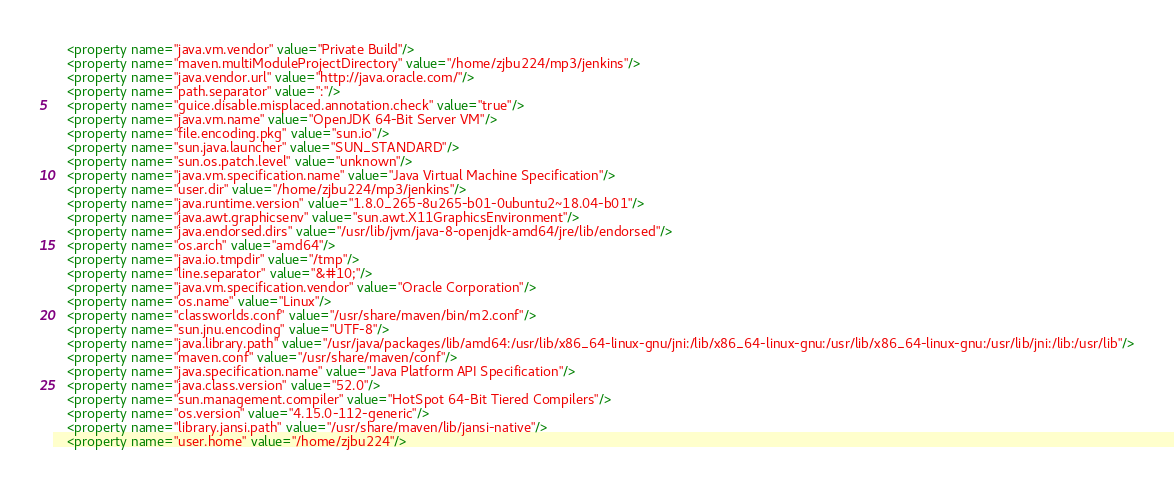<code> <loc_0><loc_0><loc_500><loc_500><_XML_>    <property name="java.vm.vendor" value="Private Build"/>
    <property name="maven.multiModuleProjectDirectory" value="/home/zjbu224/mp3/jenkins"/>
    <property name="java.vendor.url" value="http://java.oracle.com/"/>
    <property name="path.separator" value=":"/>
    <property name="guice.disable.misplaced.annotation.check" value="true"/>
    <property name="java.vm.name" value="OpenJDK 64-Bit Server VM"/>
    <property name="file.encoding.pkg" value="sun.io"/>
    <property name="sun.java.launcher" value="SUN_STANDARD"/>
    <property name="sun.os.patch.level" value="unknown"/>
    <property name="java.vm.specification.name" value="Java Virtual Machine Specification"/>
    <property name="user.dir" value="/home/zjbu224/mp3/jenkins"/>
    <property name="java.runtime.version" value="1.8.0_265-8u265-b01-0ubuntu2~18.04-b01"/>
    <property name="java.awt.graphicsenv" value="sun.awt.X11GraphicsEnvironment"/>
    <property name="java.endorsed.dirs" value="/usr/lib/jvm/java-8-openjdk-amd64/jre/lib/endorsed"/>
    <property name="os.arch" value="amd64"/>
    <property name="java.io.tmpdir" value="/tmp"/>
    <property name="line.separator" value="&#10;"/>
    <property name="java.vm.specification.vendor" value="Oracle Corporation"/>
    <property name="os.name" value="Linux"/>
    <property name="classworlds.conf" value="/usr/share/maven/bin/m2.conf"/>
    <property name="sun.jnu.encoding" value="UTF-8"/>
    <property name="java.library.path" value="/usr/java/packages/lib/amd64:/usr/lib/x86_64-linux-gnu/jni:/lib/x86_64-linux-gnu:/usr/lib/x86_64-linux-gnu:/usr/lib/jni:/lib:/usr/lib"/>
    <property name="maven.conf" value="/usr/share/maven/conf"/>
    <property name="java.specification.name" value="Java Platform API Specification"/>
    <property name="java.class.version" value="52.0"/>
    <property name="sun.management.compiler" value="HotSpot 64-Bit Tiered Compilers"/>
    <property name="os.version" value="4.15.0-112-generic"/>
    <property name="library.jansi.path" value="/usr/share/maven/lib/jansi-native"/>
    <property name="user.home" value="/home/zjbu224"/></code> 